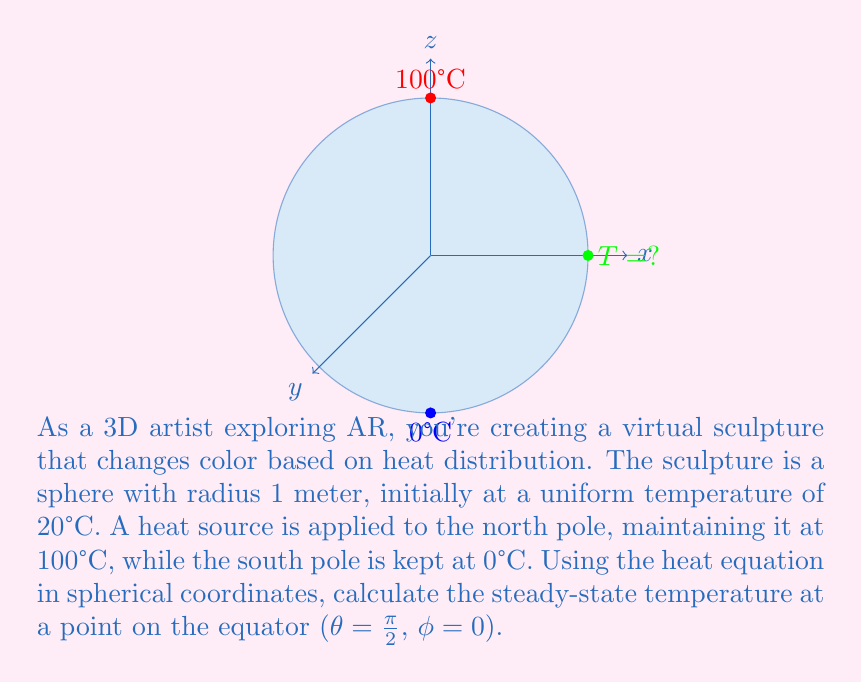Teach me how to tackle this problem. To solve this problem, we'll use the heat equation in spherical coordinates for steady-state conditions:

1) The steady-state heat equation in spherical coordinates is:
   $$\frac{1}{r^2}\frac{\partial}{\partial r}\left(r^2\frac{\partial T}{\partial r}\right) + \frac{1}{r^2\sin\theta}\frac{\partial}{\partial \theta}\left(\sin\theta\frac{\partial T}{\partial \theta}\right) + \frac{1}{r^2\sin^2\theta}\frac{\partial^2 T}{\partial \phi^2} = 0$$

2) Due to the symmetry of our problem (temperature only depends on θ), this simplifies to:
   $$\frac{1}{r^2}\frac{\partial}{\partial r}\left(r^2\frac{\partial T}{\partial r}\right) + \frac{1}{r^2\sin\theta}\frac{\partial}{\partial \theta}\left(\sin\theta\frac{\partial T}{\partial \theta}\right) = 0$$

3) For a sphere of radius 1, the solution is of the form:
   $$T(r,\theta) = \sum_{n=0}^{\infty} (A_n r^n + B_n r^{-n-1})P_n(\cos\theta)$$
   where $P_n$ are Legendre polynomials.

4) Given our boundary conditions (T = 100°C at θ = 0, T = 0°C at θ = π), only the n = 1 term remains:
   $$T(r,\theta) = A + B\cos\theta$$

5) Applying the boundary conditions:
   At θ = 0: 100 = A + B
   At θ = π: 0 = A - B

6) Solving these equations:
   A = 50, B = 50

7) Therefore, the temperature distribution is:
   $$T(\theta) = 50 + 50\cos\theta$$

8) At the equator, θ = π/2, so:
   $$T(\pi/2) = 50 + 50\cos(\pi/2) = 50 + 50(0) = 50$$
Answer: 50°C 